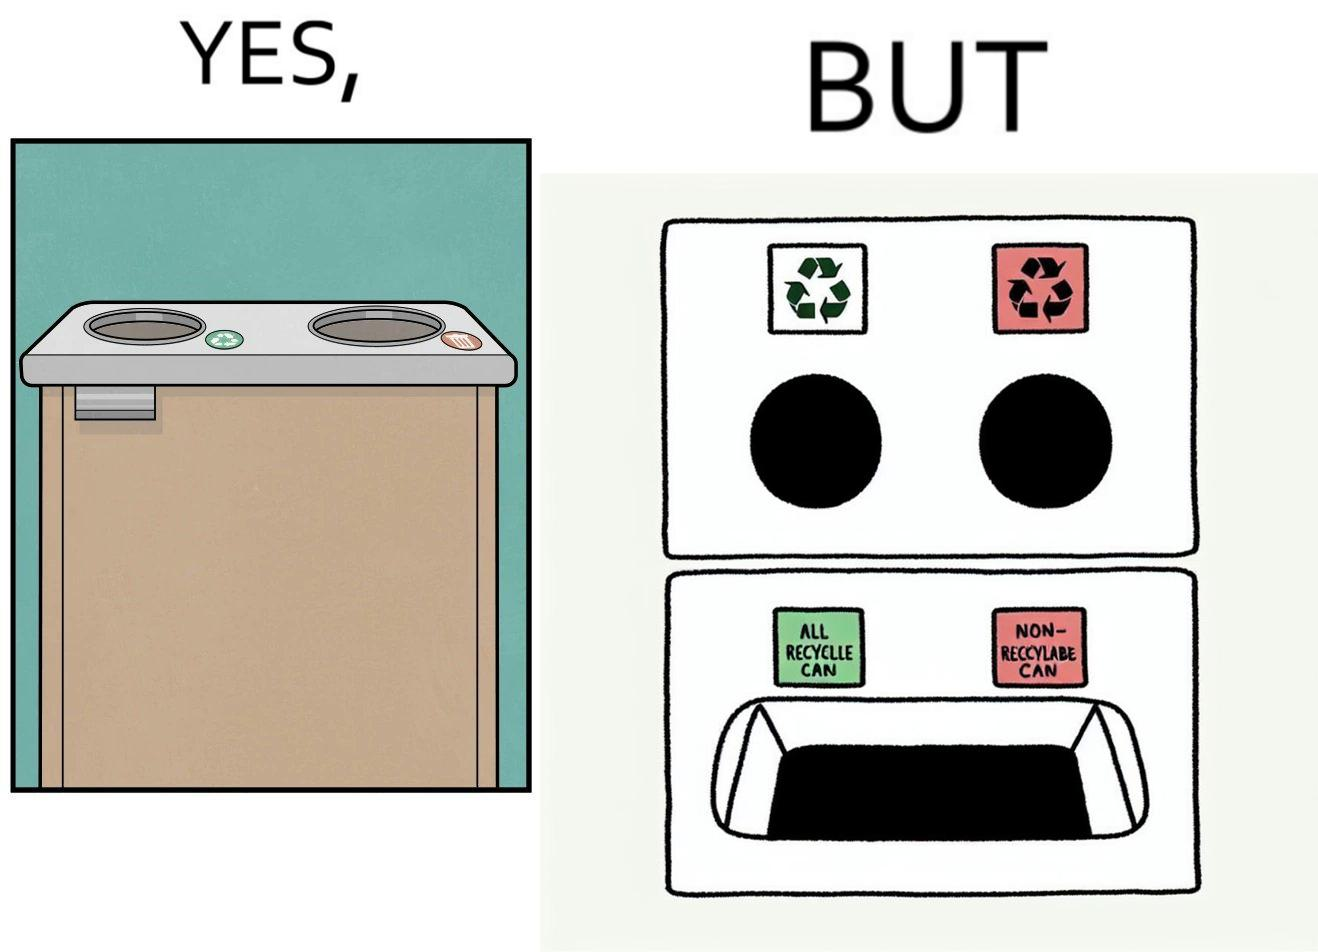What is shown in this image? The image is funny because while there are different holes provided to dump different kinds of waste, the separation is meaningless because the underlying bin which is the same. So all kinds of trash is collected together and can not be used for recycling. 